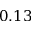<formula> <loc_0><loc_0><loc_500><loc_500>0 . 1 3</formula> 